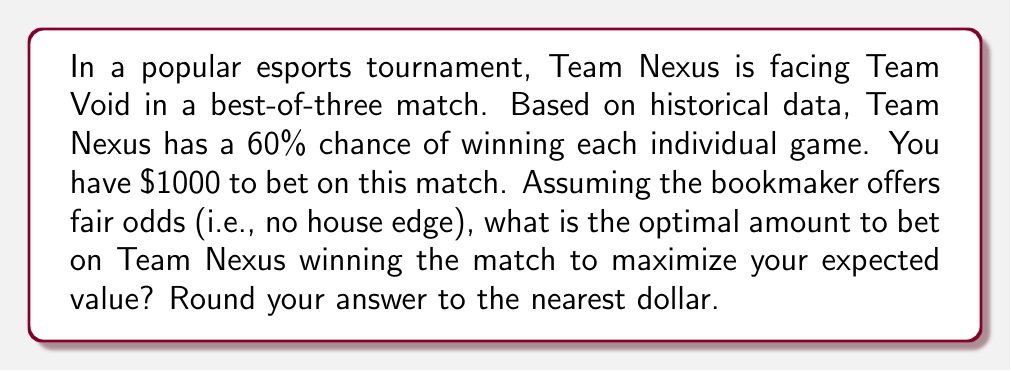Teach me how to tackle this problem. To solve this problem, we'll use the Kelly Criterion, which is a formula used to determine the optimal bet size in a favorable game. Let's break it down step-by-step:

1) First, we need to calculate the probability of Team Nexus winning the match. In a best-of-three, they need to win 2 games. The probability is:

   $P(\text{win match}) = P(\text{win 2-0}) + P(\text{win 2-1})$
   $= 0.6 \times 0.6 + 0.6 \times 0.4 \times 0.6$
   $= 0.36 + 0.144 = 0.504$

2) The fair odds for this bet would be $1/0.504 = 1.984$. This means for every $1 bet, you would win $1.984 if Team Nexus wins.

3) The Kelly Criterion formula is:

   $f^* = \frac{p(b+1)-1}{b}$

   Where:
   $f^*$ is the fraction of the bankroll to bet
   $p$ is the probability of winning
   $b$ is the net odds received on the bet (odds - 1)

4) Plugging in our values:

   $f^* = \frac{0.504(1.984-1+1)-1}{1.984-1}$
   $= \frac{0.504(2.984)-1}{0.984}$
   $= \frac{1.504-1}{0.984}$
   $= \frac{0.504}{0.984}$
   $\approx 0.512$

5) This means the optimal bet is approximately 51.2% of your bankroll.

6) With a $1000 bankroll, the optimal bet is:

   $1000 \times 0.512 = $512$

Rounding to the nearest dollar gives us $512.
Answer: $512 